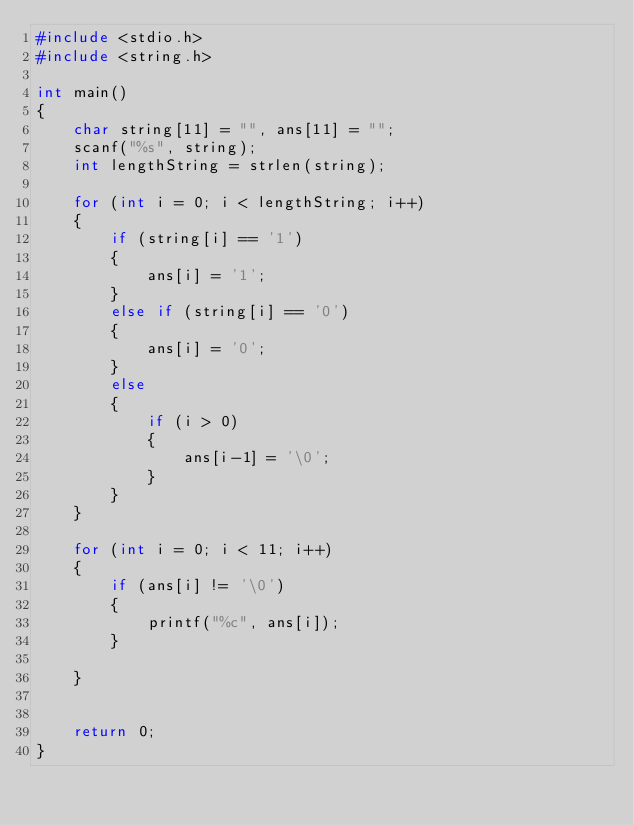<code> <loc_0><loc_0><loc_500><loc_500><_C_>#include <stdio.h>
#include <string.h>

int main()
{
    char string[11] = "", ans[11] = "";
    scanf("%s", string);
    int lengthString = strlen(string);

    for (int i = 0; i < lengthString; i++)
    {
        if (string[i] == '1')
        {
            ans[i] = '1';
        }
        else if (string[i] == '0')
        {
            ans[i] = '0';
        }
        else
        {
            if (i > 0)
            {
                ans[i-1] = '\0';
            }
        }
    }
    
    for (int i = 0; i < 11; i++)
    {
        if (ans[i] != '\0')
        {
            printf("%c", ans[i]);
        }
        
    }
    

    return 0;
}
</code> 